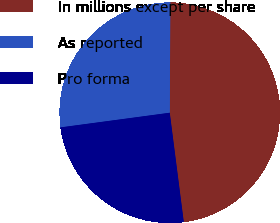Convert chart. <chart><loc_0><loc_0><loc_500><loc_500><pie_chart><fcel>In millions except per share<fcel>As reported<fcel>Pro forma<nl><fcel>47.88%<fcel>27.21%<fcel>24.91%<nl></chart> 